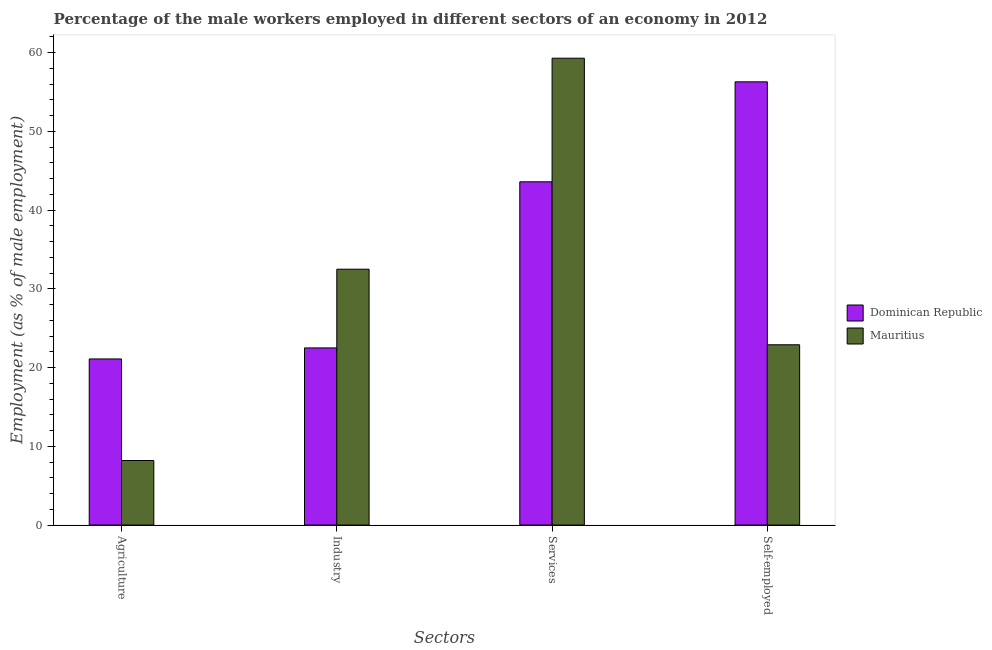How many different coloured bars are there?
Provide a short and direct response. 2. How many groups of bars are there?
Your answer should be compact. 4. Are the number of bars per tick equal to the number of legend labels?
Provide a succinct answer. Yes. Are the number of bars on each tick of the X-axis equal?
Your answer should be very brief. Yes. How many bars are there on the 1st tick from the left?
Give a very brief answer. 2. What is the label of the 4th group of bars from the left?
Your answer should be compact. Self-employed. Across all countries, what is the maximum percentage of male workers in services?
Provide a short and direct response. 59.3. Across all countries, what is the minimum percentage of self employed male workers?
Provide a short and direct response. 22.9. In which country was the percentage of male workers in services maximum?
Offer a terse response. Mauritius. In which country was the percentage of self employed male workers minimum?
Ensure brevity in your answer.  Mauritius. What is the total percentage of male workers in services in the graph?
Offer a terse response. 102.9. What is the difference between the percentage of male workers in agriculture in Dominican Republic and that in Mauritius?
Ensure brevity in your answer.  12.9. What is the difference between the percentage of male workers in services in Dominican Republic and the percentage of male workers in agriculture in Mauritius?
Your answer should be very brief. 35.4. What is the average percentage of male workers in services per country?
Offer a terse response. 51.45. What is the difference between the percentage of self employed male workers and percentage of male workers in industry in Dominican Republic?
Give a very brief answer. 33.8. What is the ratio of the percentage of male workers in industry in Dominican Republic to that in Mauritius?
Your answer should be compact. 0.69. What is the difference between the highest and the second highest percentage of male workers in services?
Provide a short and direct response. 15.7. What is the difference between the highest and the lowest percentage of male workers in services?
Make the answer very short. 15.7. Is it the case that in every country, the sum of the percentage of male workers in services and percentage of male workers in agriculture is greater than the sum of percentage of male workers in industry and percentage of self employed male workers?
Your answer should be compact. No. What does the 1st bar from the left in Self-employed represents?
Offer a terse response. Dominican Republic. What does the 1st bar from the right in Self-employed represents?
Your answer should be very brief. Mauritius. Is it the case that in every country, the sum of the percentage of male workers in agriculture and percentage of male workers in industry is greater than the percentage of male workers in services?
Provide a short and direct response. No. Are all the bars in the graph horizontal?
Make the answer very short. No. Does the graph contain any zero values?
Give a very brief answer. No. What is the title of the graph?
Ensure brevity in your answer.  Percentage of the male workers employed in different sectors of an economy in 2012. Does "Middle East & North Africa (all income levels)" appear as one of the legend labels in the graph?
Make the answer very short. No. What is the label or title of the X-axis?
Your answer should be very brief. Sectors. What is the label or title of the Y-axis?
Your answer should be compact. Employment (as % of male employment). What is the Employment (as % of male employment) of Dominican Republic in Agriculture?
Your answer should be very brief. 21.1. What is the Employment (as % of male employment) of Mauritius in Agriculture?
Your answer should be very brief. 8.2. What is the Employment (as % of male employment) of Mauritius in Industry?
Give a very brief answer. 32.5. What is the Employment (as % of male employment) of Dominican Republic in Services?
Offer a very short reply. 43.6. What is the Employment (as % of male employment) in Mauritius in Services?
Give a very brief answer. 59.3. What is the Employment (as % of male employment) in Dominican Republic in Self-employed?
Your response must be concise. 56.3. What is the Employment (as % of male employment) of Mauritius in Self-employed?
Provide a short and direct response. 22.9. Across all Sectors, what is the maximum Employment (as % of male employment) of Dominican Republic?
Keep it short and to the point. 56.3. Across all Sectors, what is the maximum Employment (as % of male employment) in Mauritius?
Your answer should be compact. 59.3. Across all Sectors, what is the minimum Employment (as % of male employment) in Dominican Republic?
Your response must be concise. 21.1. Across all Sectors, what is the minimum Employment (as % of male employment) in Mauritius?
Provide a succinct answer. 8.2. What is the total Employment (as % of male employment) in Dominican Republic in the graph?
Your response must be concise. 143.5. What is the total Employment (as % of male employment) of Mauritius in the graph?
Offer a very short reply. 122.9. What is the difference between the Employment (as % of male employment) in Dominican Republic in Agriculture and that in Industry?
Offer a very short reply. -1.4. What is the difference between the Employment (as % of male employment) of Mauritius in Agriculture and that in Industry?
Give a very brief answer. -24.3. What is the difference between the Employment (as % of male employment) of Dominican Republic in Agriculture and that in Services?
Give a very brief answer. -22.5. What is the difference between the Employment (as % of male employment) of Mauritius in Agriculture and that in Services?
Make the answer very short. -51.1. What is the difference between the Employment (as % of male employment) of Dominican Republic in Agriculture and that in Self-employed?
Keep it short and to the point. -35.2. What is the difference between the Employment (as % of male employment) of Mauritius in Agriculture and that in Self-employed?
Make the answer very short. -14.7. What is the difference between the Employment (as % of male employment) in Dominican Republic in Industry and that in Services?
Your answer should be compact. -21.1. What is the difference between the Employment (as % of male employment) of Mauritius in Industry and that in Services?
Provide a succinct answer. -26.8. What is the difference between the Employment (as % of male employment) in Dominican Republic in Industry and that in Self-employed?
Offer a very short reply. -33.8. What is the difference between the Employment (as % of male employment) of Mauritius in Industry and that in Self-employed?
Give a very brief answer. 9.6. What is the difference between the Employment (as % of male employment) in Mauritius in Services and that in Self-employed?
Your answer should be compact. 36.4. What is the difference between the Employment (as % of male employment) in Dominican Republic in Agriculture and the Employment (as % of male employment) in Mauritius in Services?
Provide a short and direct response. -38.2. What is the difference between the Employment (as % of male employment) of Dominican Republic in Industry and the Employment (as % of male employment) of Mauritius in Services?
Make the answer very short. -36.8. What is the difference between the Employment (as % of male employment) in Dominican Republic in Services and the Employment (as % of male employment) in Mauritius in Self-employed?
Provide a short and direct response. 20.7. What is the average Employment (as % of male employment) of Dominican Republic per Sectors?
Provide a short and direct response. 35.88. What is the average Employment (as % of male employment) of Mauritius per Sectors?
Offer a terse response. 30.73. What is the difference between the Employment (as % of male employment) of Dominican Republic and Employment (as % of male employment) of Mauritius in Agriculture?
Make the answer very short. 12.9. What is the difference between the Employment (as % of male employment) in Dominican Republic and Employment (as % of male employment) in Mauritius in Industry?
Your response must be concise. -10. What is the difference between the Employment (as % of male employment) of Dominican Republic and Employment (as % of male employment) of Mauritius in Services?
Ensure brevity in your answer.  -15.7. What is the difference between the Employment (as % of male employment) in Dominican Republic and Employment (as % of male employment) in Mauritius in Self-employed?
Your answer should be very brief. 33.4. What is the ratio of the Employment (as % of male employment) of Dominican Republic in Agriculture to that in Industry?
Give a very brief answer. 0.94. What is the ratio of the Employment (as % of male employment) in Mauritius in Agriculture to that in Industry?
Ensure brevity in your answer.  0.25. What is the ratio of the Employment (as % of male employment) of Dominican Republic in Agriculture to that in Services?
Give a very brief answer. 0.48. What is the ratio of the Employment (as % of male employment) of Mauritius in Agriculture to that in Services?
Your answer should be compact. 0.14. What is the ratio of the Employment (as % of male employment) of Dominican Republic in Agriculture to that in Self-employed?
Keep it short and to the point. 0.37. What is the ratio of the Employment (as % of male employment) in Mauritius in Agriculture to that in Self-employed?
Give a very brief answer. 0.36. What is the ratio of the Employment (as % of male employment) in Dominican Republic in Industry to that in Services?
Offer a terse response. 0.52. What is the ratio of the Employment (as % of male employment) in Mauritius in Industry to that in Services?
Your answer should be compact. 0.55. What is the ratio of the Employment (as % of male employment) of Dominican Republic in Industry to that in Self-employed?
Give a very brief answer. 0.4. What is the ratio of the Employment (as % of male employment) in Mauritius in Industry to that in Self-employed?
Provide a short and direct response. 1.42. What is the ratio of the Employment (as % of male employment) in Dominican Republic in Services to that in Self-employed?
Your answer should be compact. 0.77. What is the ratio of the Employment (as % of male employment) of Mauritius in Services to that in Self-employed?
Keep it short and to the point. 2.59. What is the difference between the highest and the second highest Employment (as % of male employment) in Mauritius?
Provide a succinct answer. 26.8. What is the difference between the highest and the lowest Employment (as % of male employment) of Dominican Republic?
Your response must be concise. 35.2. What is the difference between the highest and the lowest Employment (as % of male employment) in Mauritius?
Offer a very short reply. 51.1. 